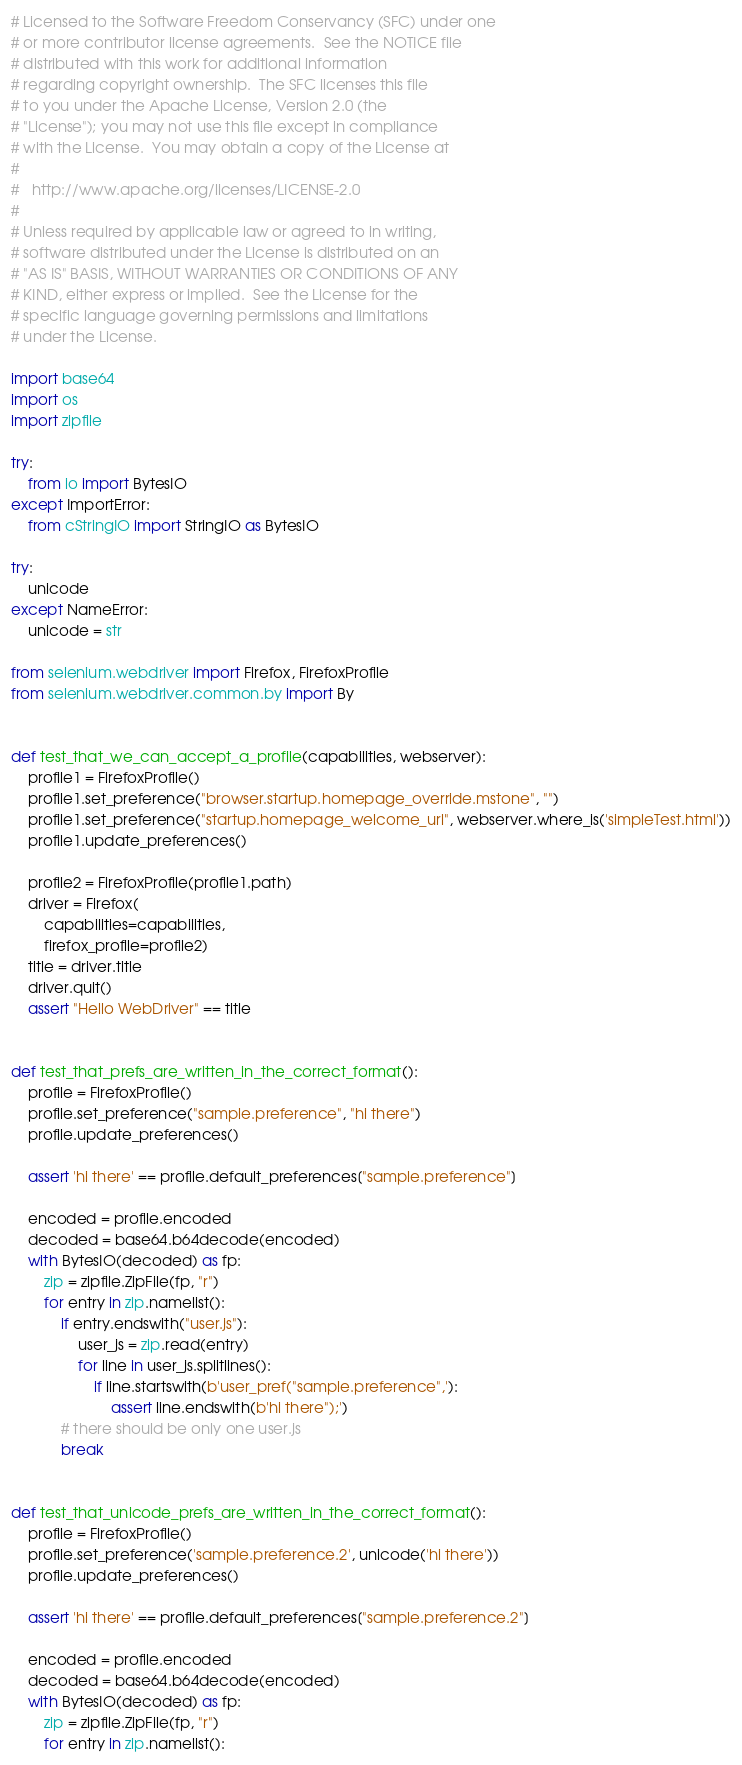<code> <loc_0><loc_0><loc_500><loc_500><_Python_># Licensed to the Software Freedom Conservancy (SFC) under one
# or more contributor license agreements.  See the NOTICE file
# distributed with this work for additional information
# regarding copyright ownership.  The SFC licenses this file
# to you under the Apache License, Version 2.0 (the
# "License"); you may not use this file except in compliance
# with the License.  You may obtain a copy of the License at
#
#   http://www.apache.org/licenses/LICENSE-2.0
#
# Unless required by applicable law or agreed to in writing,
# software distributed under the License is distributed on an
# "AS IS" BASIS, WITHOUT WARRANTIES OR CONDITIONS OF ANY
# KIND, either express or implied.  See the License for the
# specific language governing permissions and limitations
# under the License.

import base64
import os
import zipfile

try:
    from io import BytesIO
except ImportError:
    from cStringIO import StringIO as BytesIO

try:
    unicode
except NameError:
    unicode = str

from selenium.webdriver import Firefox, FirefoxProfile
from selenium.webdriver.common.by import By


def test_that_we_can_accept_a_profile(capabilities, webserver):
    profile1 = FirefoxProfile()
    profile1.set_preference("browser.startup.homepage_override.mstone", "")
    profile1.set_preference("startup.homepage_welcome_url", webserver.where_is('simpleTest.html'))
    profile1.update_preferences()

    profile2 = FirefoxProfile(profile1.path)
    driver = Firefox(
        capabilities=capabilities,
        firefox_profile=profile2)
    title = driver.title
    driver.quit()
    assert "Hello WebDriver" == title


def test_that_prefs_are_written_in_the_correct_format():
    profile = FirefoxProfile()
    profile.set_preference("sample.preference", "hi there")
    profile.update_preferences()

    assert 'hi there' == profile.default_preferences["sample.preference"]

    encoded = profile.encoded
    decoded = base64.b64decode(encoded)
    with BytesIO(decoded) as fp:
        zip = zipfile.ZipFile(fp, "r")
        for entry in zip.namelist():
            if entry.endswith("user.js"):
                user_js = zip.read(entry)
                for line in user_js.splitlines():
                    if line.startswith(b'user_pref("sample.preference",'):
                        assert line.endswith(b'hi there");')
            # there should be only one user.js
            break


def test_that_unicode_prefs_are_written_in_the_correct_format():
    profile = FirefoxProfile()
    profile.set_preference('sample.preference.2', unicode('hi there'))
    profile.update_preferences()

    assert 'hi there' == profile.default_preferences["sample.preference.2"]

    encoded = profile.encoded
    decoded = base64.b64decode(encoded)
    with BytesIO(decoded) as fp:
        zip = zipfile.ZipFile(fp, "r")
        for entry in zip.namelist():</code> 